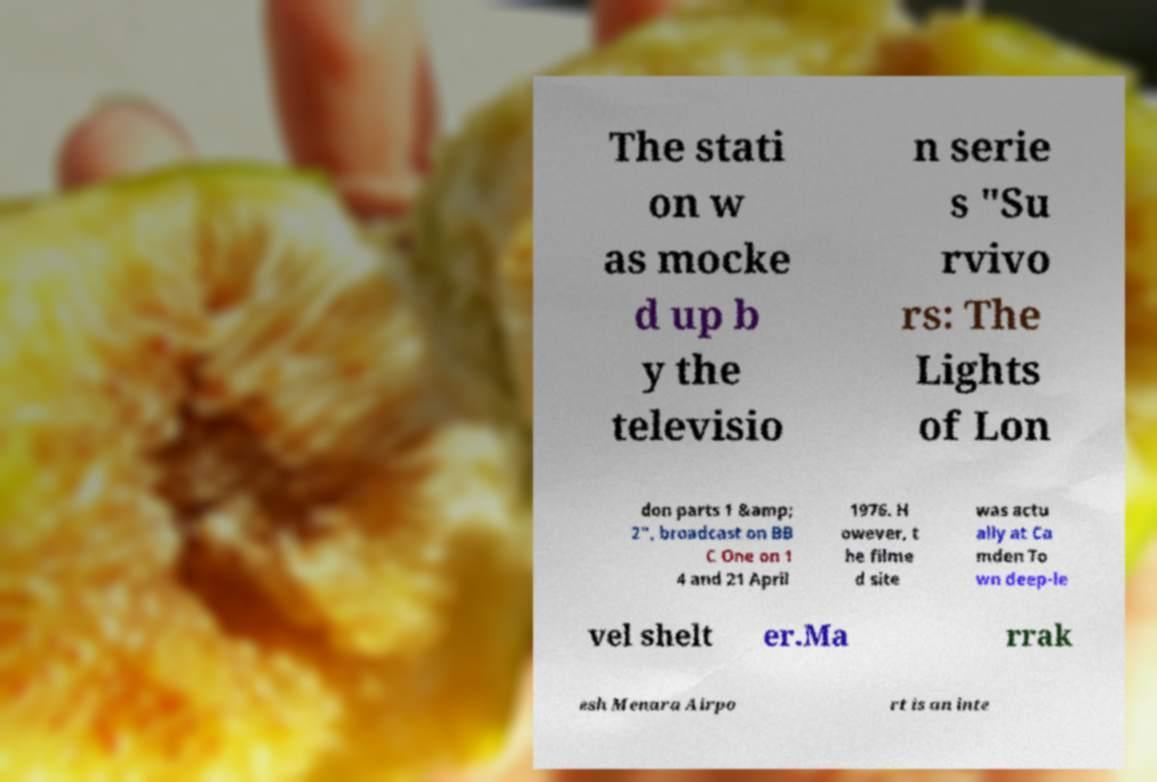Can you accurately transcribe the text from the provided image for me? The stati on w as mocke d up b y the televisio n serie s "Su rvivo rs: The Lights of Lon don parts 1 &amp; 2", broadcast on BB C One on 1 4 and 21 April 1976. H owever, t he filme d site was actu ally at Ca mden To wn deep-le vel shelt er.Ma rrak esh Menara Airpo rt is an inte 